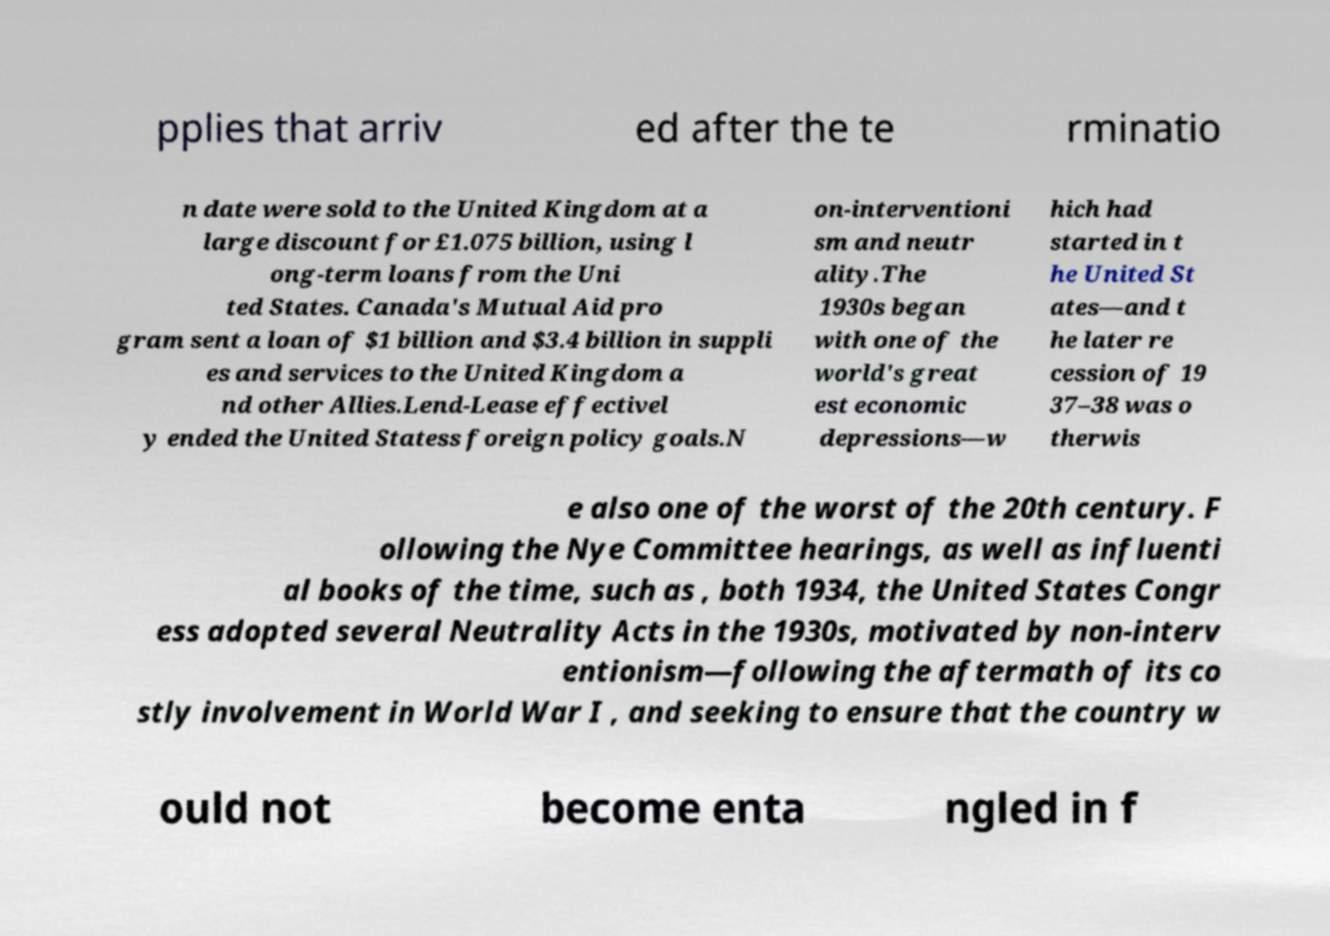Please read and relay the text visible in this image. What does it say? pplies that arriv ed after the te rminatio n date were sold to the United Kingdom at a large discount for £1.075 billion, using l ong-term loans from the Uni ted States. Canada's Mutual Aid pro gram sent a loan of $1 billion and $3.4 billion in suppli es and services to the United Kingdom a nd other Allies.Lend-Lease effectivel y ended the United Statess foreign policy goals.N on-interventioni sm and neutr ality.The 1930s began with one of the world's great est economic depressions—w hich had started in t he United St ates—and t he later re cession of 19 37–38 was o therwis e also one of the worst of the 20th century. F ollowing the Nye Committee hearings, as well as influenti al books of the time, such as , both 1934, the United States Congr ess adopted several Neutrality Acts in the 1930s, motivated by non-interv entionism—following the aftermath of its co stly involvement in World War I , and seeking to ensure that the country w ould not become enta ngled in f 